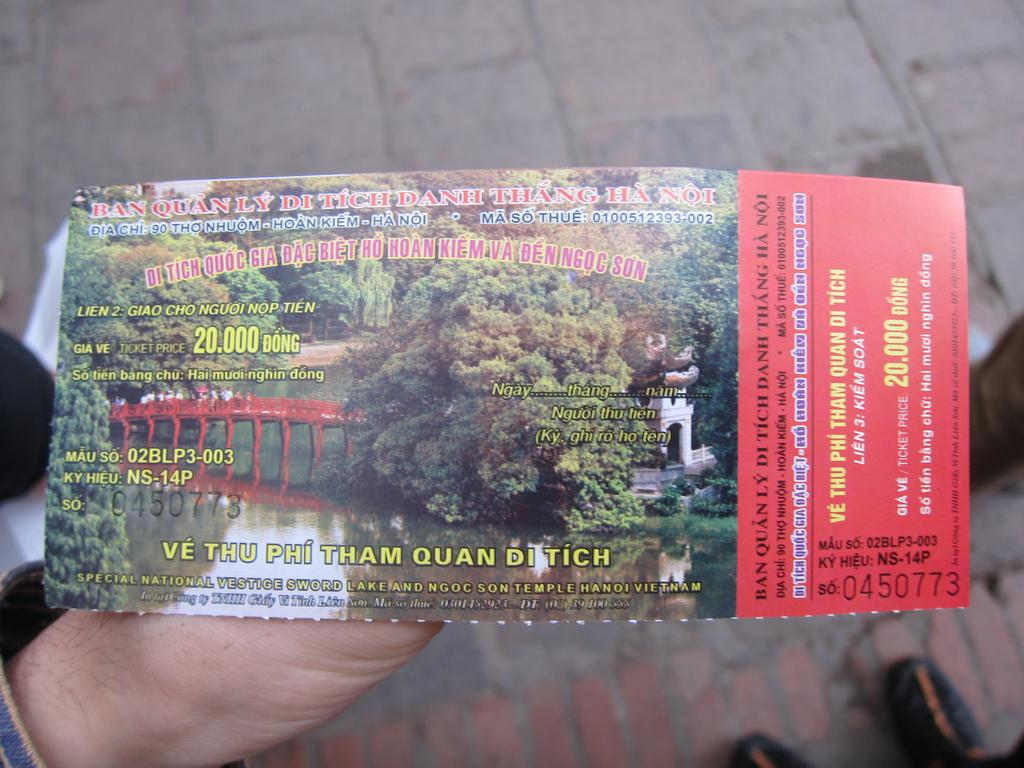<image>
Summarize the visual content of the image. Person holding a ticket that says "20.000 Dong" in yellow. 